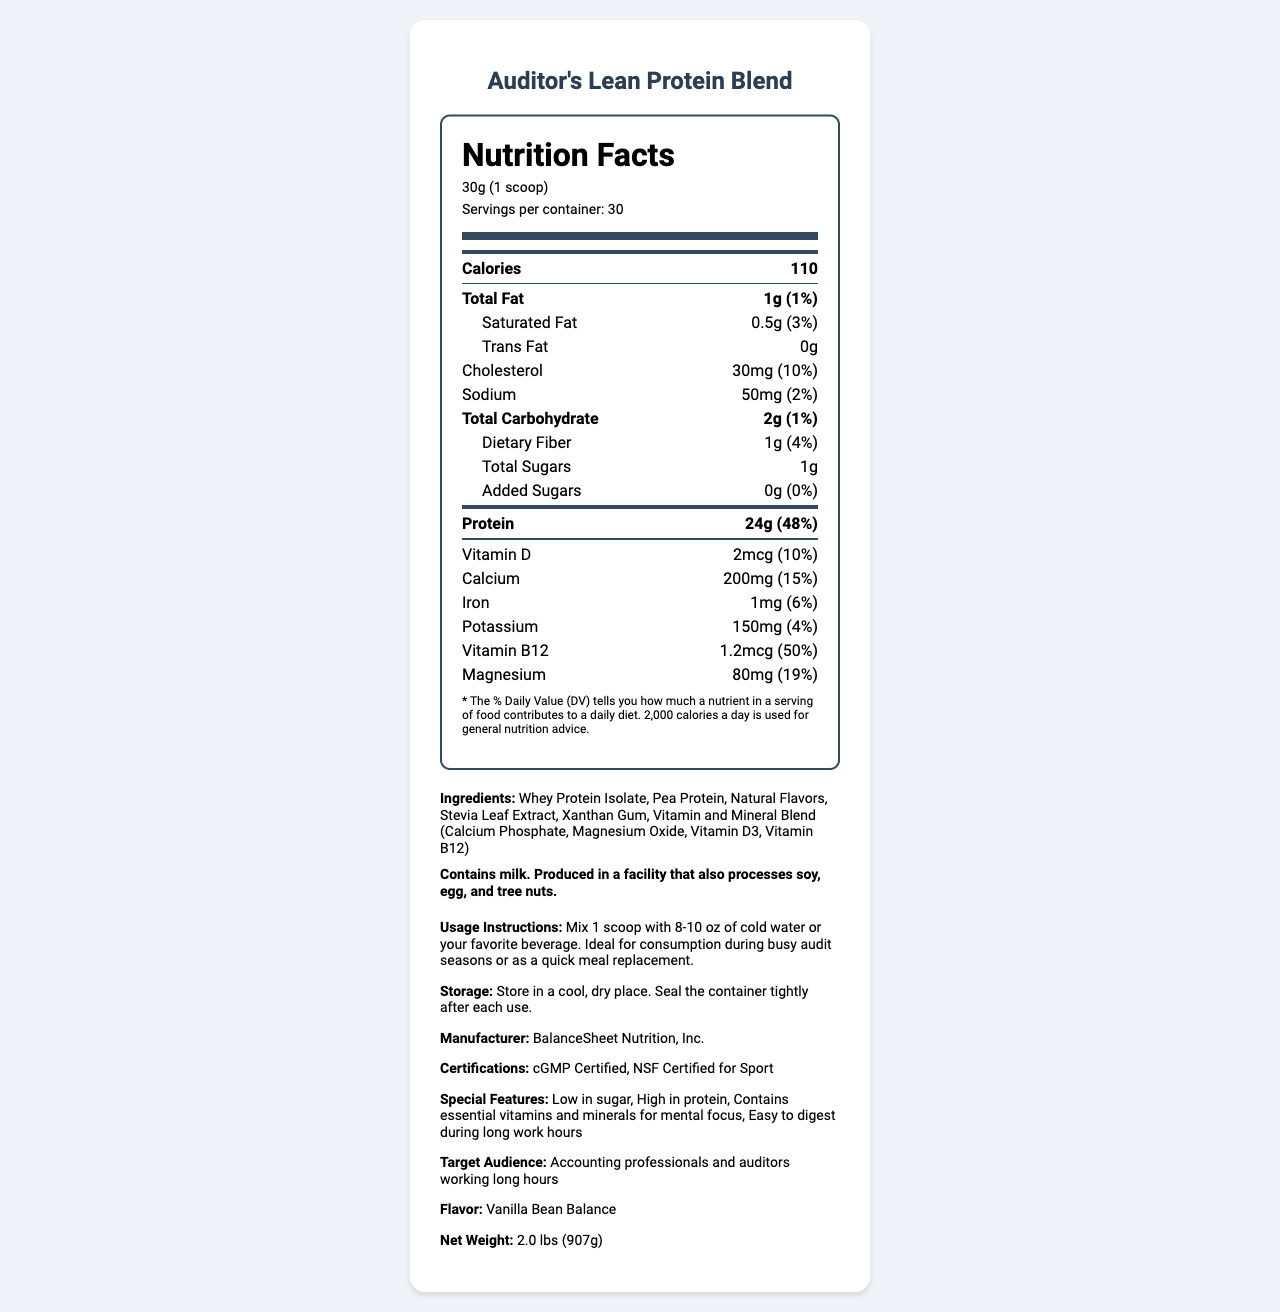what is the serving size? The serving size is specified at the beginning of the nutrition label under the product name.
Answer: 30g (1 scoop) how many servings are there per container? The number of servings per container is mentioned right after the serving size.
Answer: 30 how many calories are in one serving? The calories per serving are listed prominently within the nutrition facts.
Answer: 110 what percentage of the daily value for protein does one serving provide? The daily value percentage for protein is provided next to the protein amount.
Answer: 48% how much sodium is in one serving? The amount of sodium per serving is listed in the nutrition facts section.
Answer: 50mg how much vitamin B12 is in a serving, and what percentage of the daily value does it represent? The amount and daily value percentage for vitamin B12 are both provided in the nutrition facts label.
Answer: 1.2mcg, 50% is there any trans fat in this product? The nutrition facts indicate that there are 0g of trans fat per serving.
Answer: No which vitamins and minerals are included in the vitamin and mineral blend? The ingredients list specifies the components of the vitamin and mineral blend.
Answer: Calcium Phosphate, Magnesium Oxide, Vitamin D3, Vitamin B12 what is the recommended usage of this product? The usage instructions under the additional info section provide the recommended way to use the product.
Answer: Mix 1 scoop with 8-10 oz of cold water or your favorite beverage. Ideal for consumption during busy audit seasons or as a quick meal replacement. how much dietary fiber is in one serving, and what is its daily value percentage? Both the amount and the daily value percentage of dietary fiber are provided in the nutrition facts.
Answer: 1g, 4% how should this product be stored? The storage instructions are mentioned under the additional info section.
Answer: Store in a cool, dry place. Seal the container tightly after each use. which of the following features is NOT listed for this protein powder? A. High Protein B. Gluten-Free C. Low in Sugar D. Contains essential vitamins and minerals for mental focus The document does not mention that the product is gluten-free, while it lists the other options as special features.
Answer: B. Gluten-Free what is the net weight of the product? The net weight is listed in the additional info section at the end of the document.
Answer: 2.0 lbs (907g) who is the target audience for this product? The document explicitly states that the target audience is accounting professionals and auditors working long hours.
Answer: Accounting professionals and auditors working long hours does this product contain any milk? The allergen information states that the product contains milk.
Answer: Yes summarize the main idea of the document. The document provides comprehensive details about the nutritional content and additional information relevant to the product, aimed at a specific target audience.
Answer: The document is a nutrition facts label for a protein powder called "Auditor's Lean Protein Blend," which is designed for accounting professionals and auditors working long hours. It highlights nutritional content, serving size, ingredients, allergen information, usage instructions, storage guidelines, and special features. who is the CEO of BalanceSheet Nutrition, Inc.? The document does not provide information regarding the CEO of BalanceSheet Nutrition, Inc.
Answer: Not enough information 